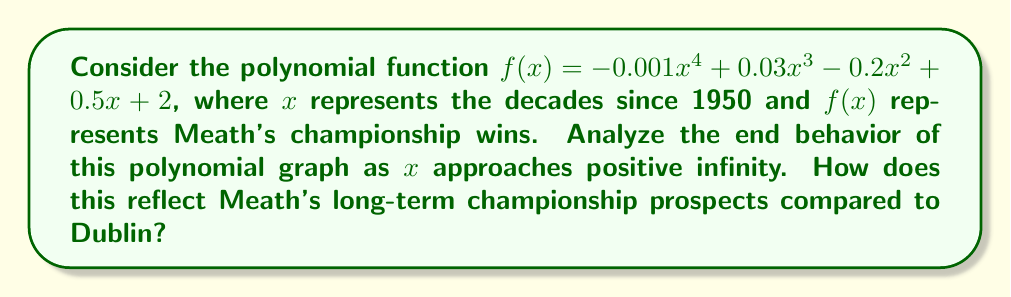Give your solution to this math problem. To analyze the end behavior of the polynomial function, we need to follow these steps:

1) Identify the leading term:
   The leading term is $-0.001x^4$, as it has the highest degree.

2) Determine the degree and sign of the leading coefficient:
   Degree: 4 (even)
   Sign of leading coefficient: Negative

3) For even-degree polynomials:
   If the leading coefficient is positive, both ends of the graph go up as $x$ approaches $\pm\infty$.
   If the leading coefficient is negative, both ends of the graph go down as $x$ approaches $\pm\infty$.

4) In this case, since the leading coefficient is negative and the degree is even:
   $$\lim_{x \to \pm\infty} f(x) = -\infty$$

5) Interpretation:
   As $x$ (decades) increases indefinitely, $f(x)$ (Meath's championship wins) will approach negative infinity. This suggests a long-term decline in Meath's championship success.

6) Comparison to Dublin:
   While not explicitly stated in the function, the implication is that Meath's championship wins will decrease over time, potentially contrasting with Dublin's success.
Answer: As $x \to \infty$, $f(x) \to -\infty$, indicating a long-term decline in Meath's championship wins. 